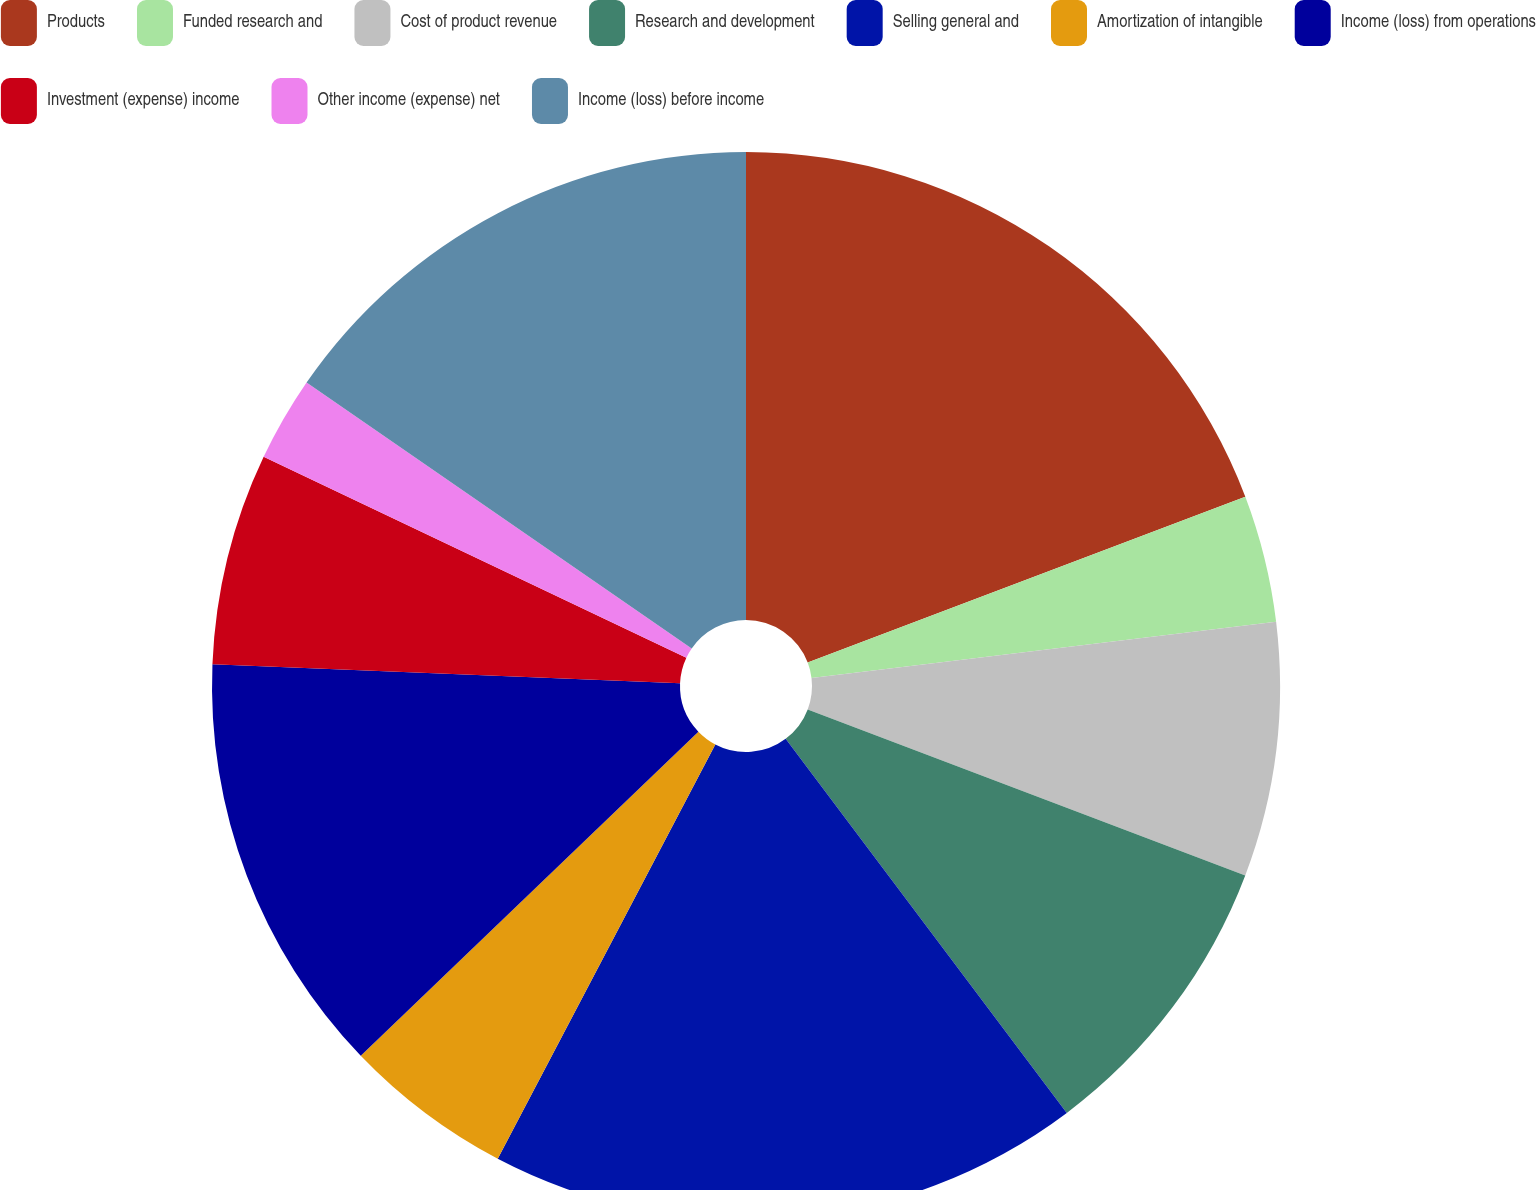<chart> <loc_0><loc_0><loc_500><loc_500><pie_chart><fcel>Products<fcel>Funded research and<fcel>Cost of product revenue<fcel>Research and development<fcel>Selling general and<fcel>Amortization of intangible<fcel>Income (loss) from operations<fcel>Investment (expense) income<fcel>Other income (expense) net<fcel>Income (loss) before income<nl><fcel>19.23%<fcel>3.85%<fcel>7.69%<fcel>8.97%<fcel>17.95%<fcel>5.13%<fcel>12.82%<fcel>6.41%<fcel>2.56%<fcel>15.38%<nl></chart> 